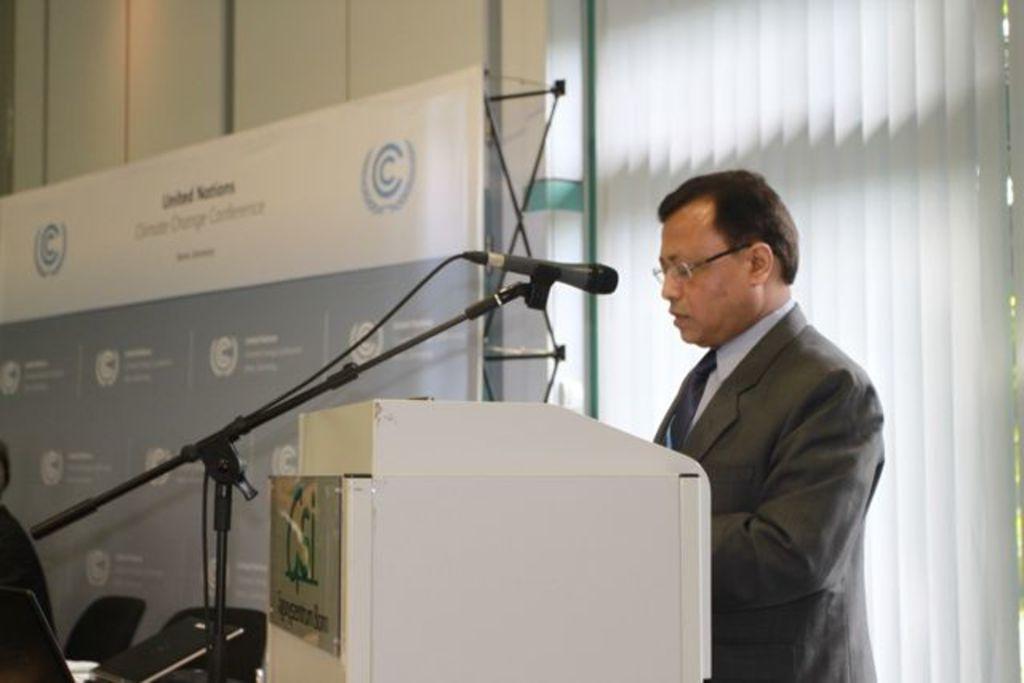How would you summarize this image in a sentence or two? In this picture we can see a person standing in front of the podium. We can see the text and a few things on a board visible on the podium. There is a laptop, chairs and window blinds. We can see the text and other things on the banner. There are other objects. 